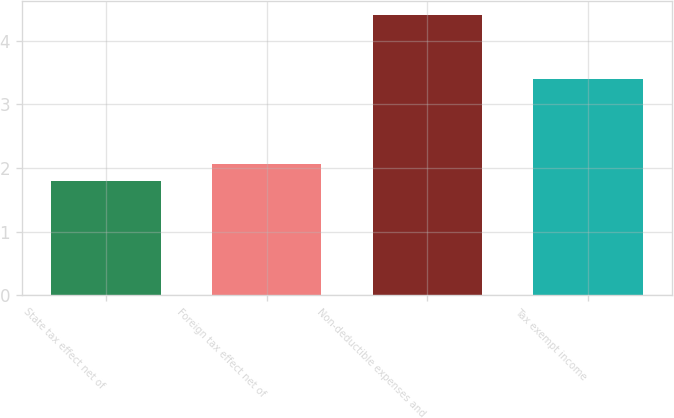Convert chart to OTSL. <chart><loc_0><loc_0><loc_500><loc_500><bar_chart><fcel>State tax effect net of<fcel>Foreign tax effect net of<fcel>Non-deductible expenses and<fcel>Tax exempt income<nl><fcel>1.8<fcel>2.06<fcel>4.4<fcel>3.4<nl></chart> 